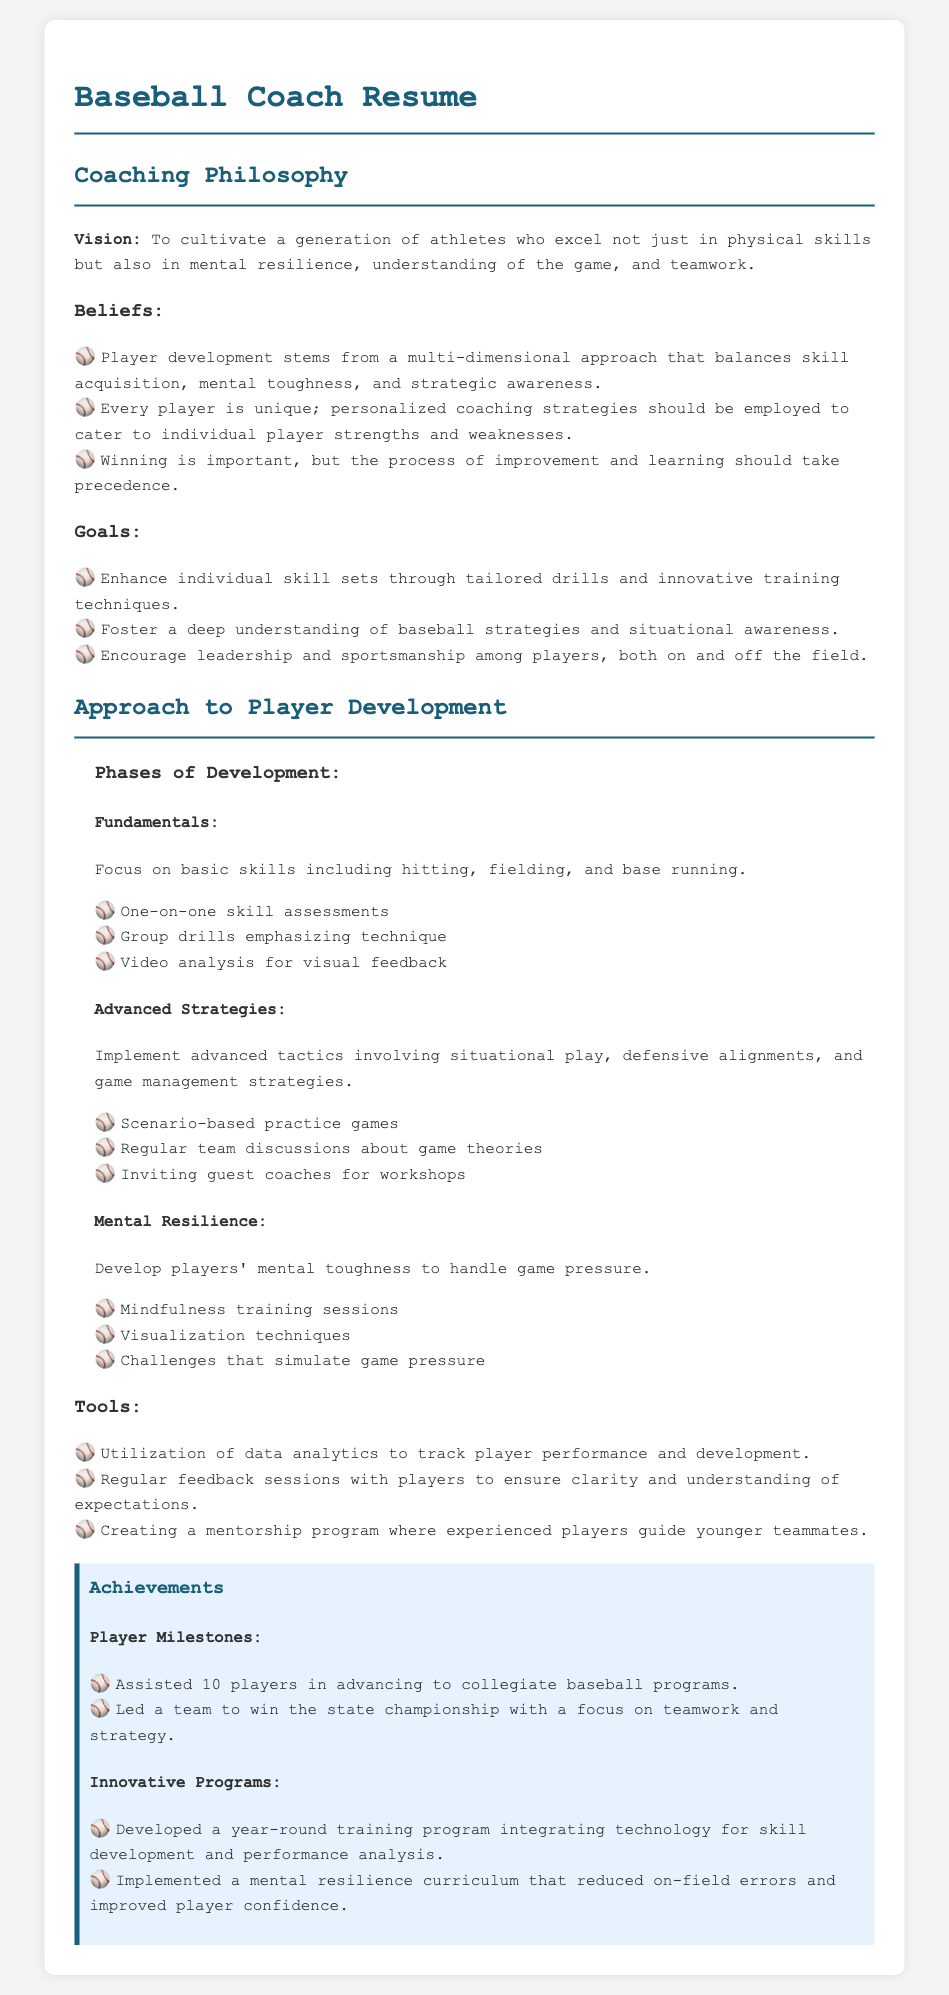What is the coaching philosophy's vision? The vision emphasizes cultivating athletes who excel in physical skills, mental resilience, and teamwork.
Answer: To cultivate a generation of athletes who excel not just in physical skills but also in mental resilience, understanding of the game, and teamwork How many players were assisted in advancing to collegiate baseball programs? The document specifies the number of players who advanced to collegiate programs.
Answer: 10 players What is the focus of the fundamentals phase in player development? The fundamentals phase centers on basic skills essential for players.
Answer: Basic skills including hitting, fielding, and base running What type of training sessions are included in the mental resilience section? The mental resilience section mentions specific methods to develop players' mental toughness.
Answer: Mindfulness training sessions What innovative program was developed according to the achievements section? The document outlines a particular innovative program that focuses on training and performance analysis.
Answer: Year-round training program integrating technology for skill development and performance analysis How does the coach view the importance of winning? The document describes the coach's perspective on winning in relation to improvement and learning processes.
Answer: Winning is important, but the process of improvement and learning should take precedence 